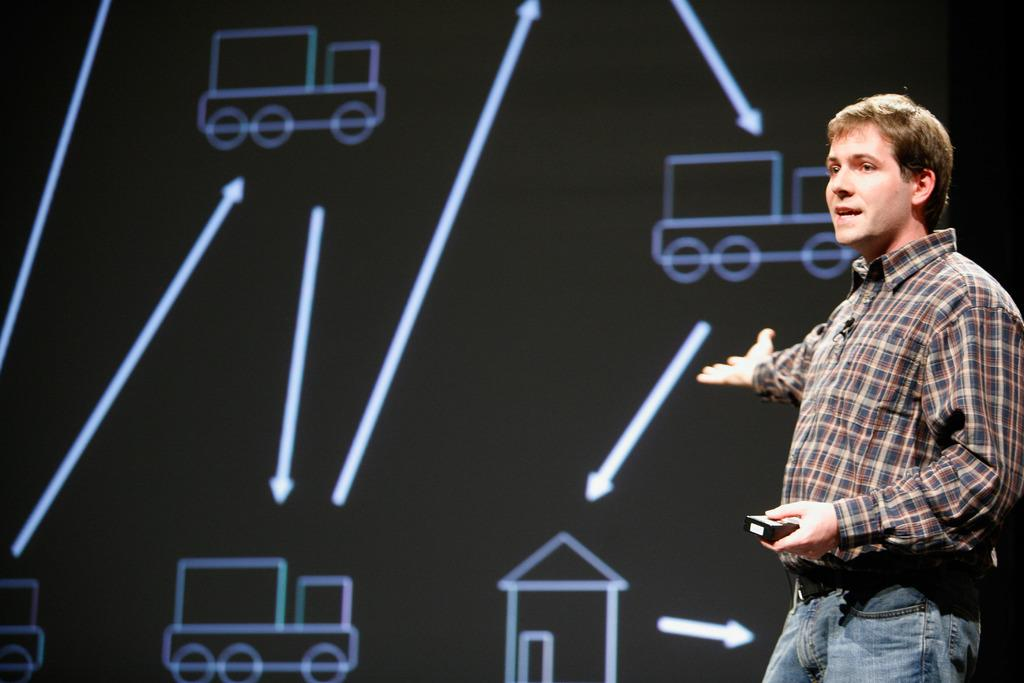What is the main subject of the image? The main subject of the image is a man. What is the man doing in the image? The man is talking in the image. What is the man holding in his hand? The man is holding an object in his hand. What can be seen in the background of the image? There is a screen in the background of the image. What type of apparel is the zephyr wearing in the image? There is no zephyr or person wearing apparel in the image; it only features a man talking and holding an object. 